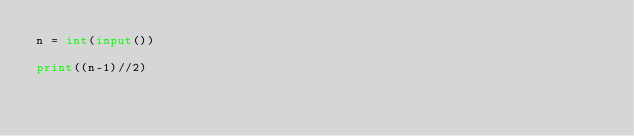Convert code to text. <code><loc_0><loc_0><loc_500><loc_500><_Python_>n = int(input())

print((n-1)//2)</code> 